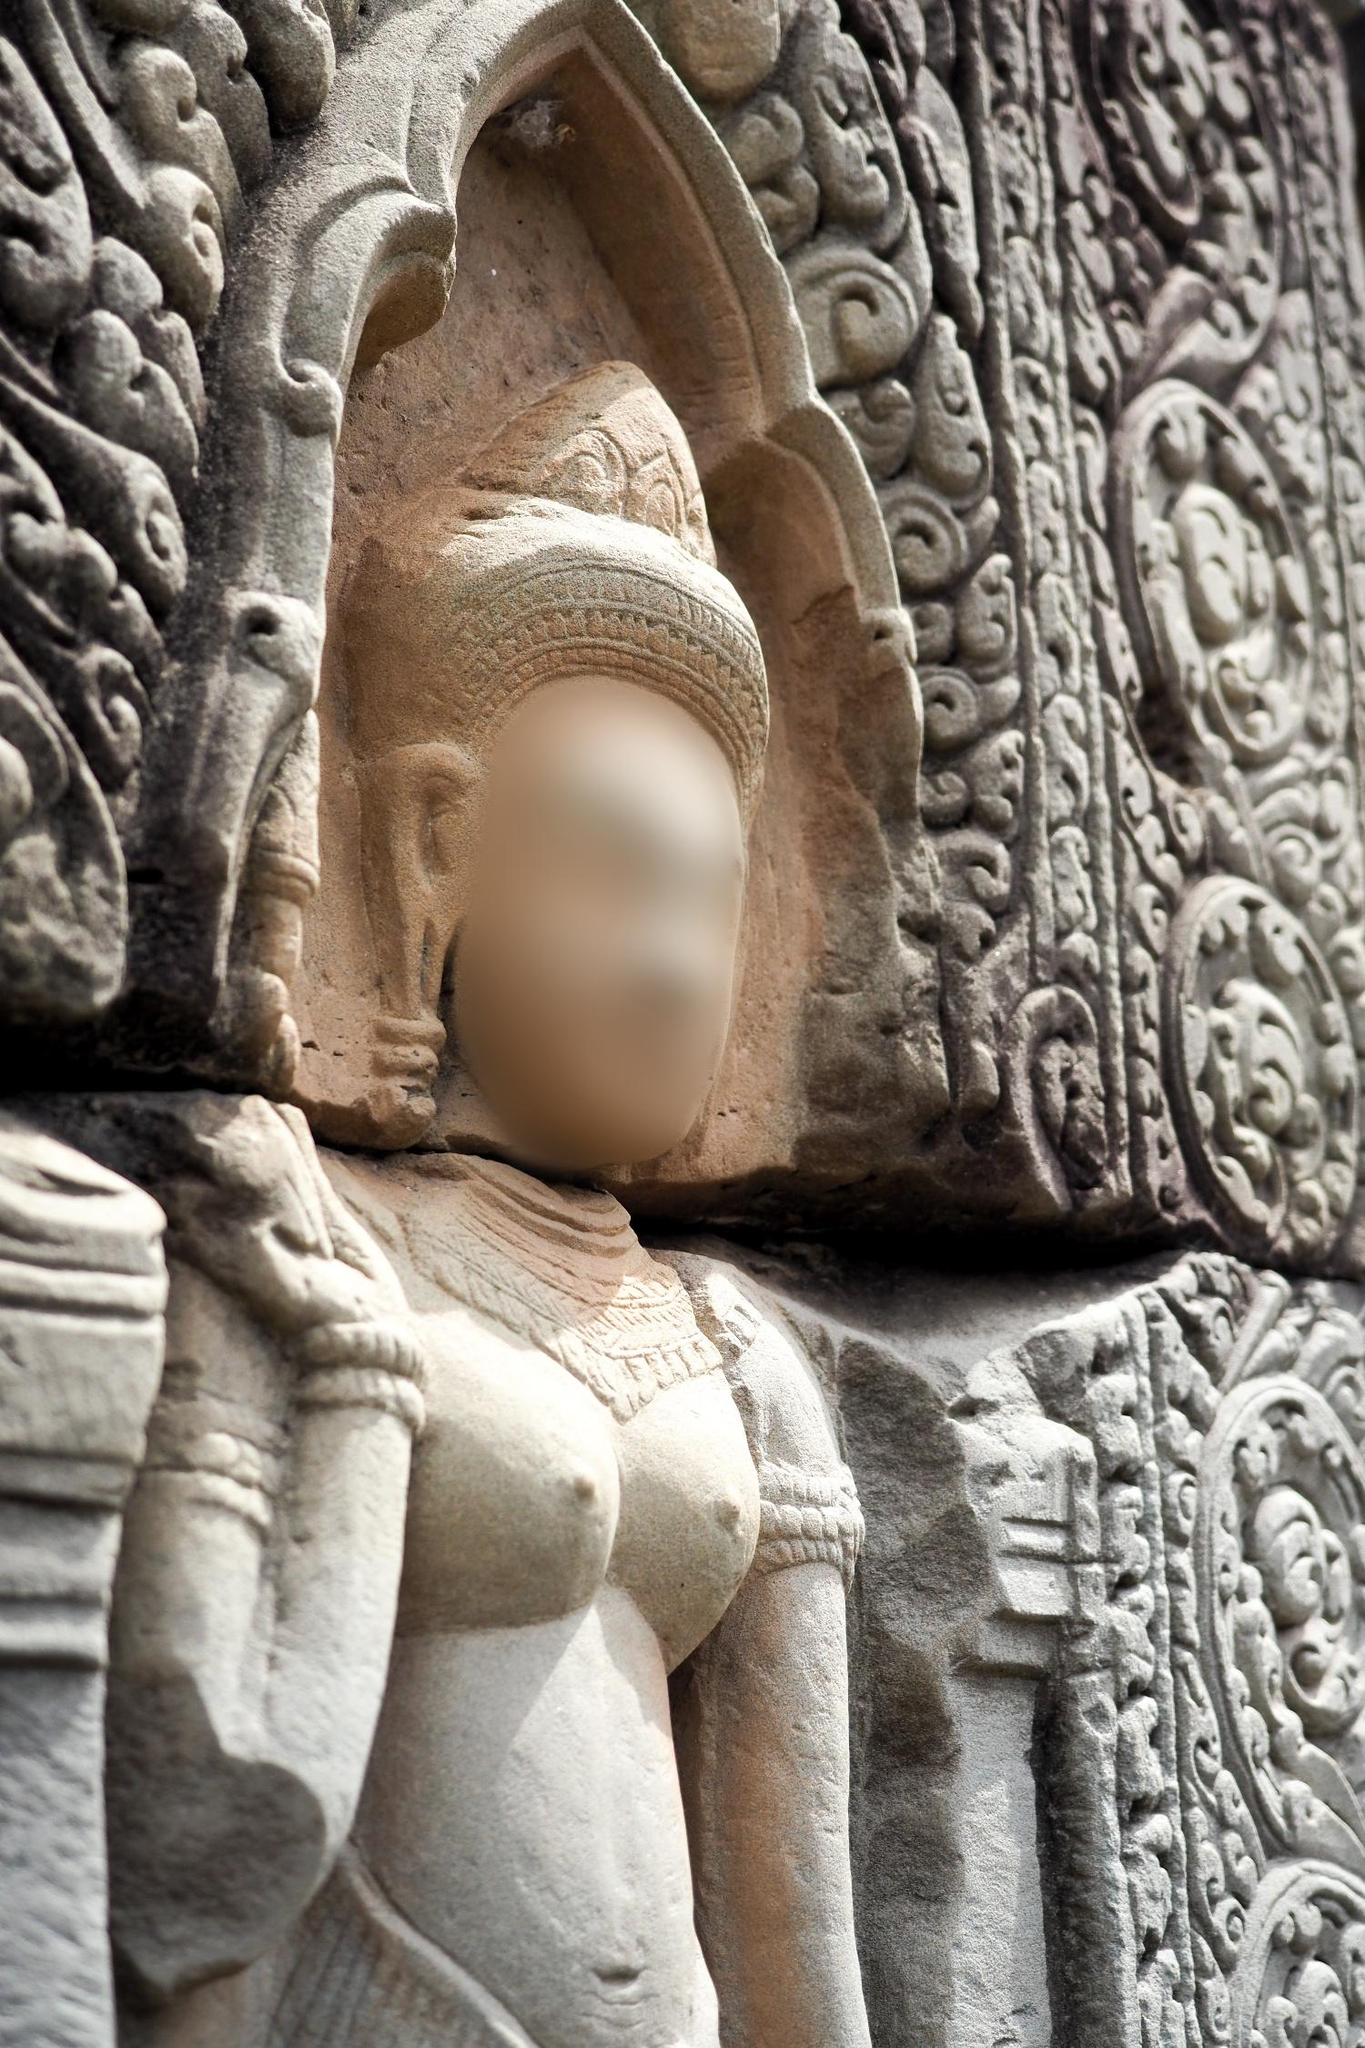Can you describe what the figure in the statue might be representing? The figure in the statue likely represents a deity or important personage from a historical or spiritual context, given the elaborate headdress and ornate detailing. The presence of intricate carvings and the timeless stone material suggest that it holds significant cultural or religious value. This could be a depiction of a revered guardian or a divine entity, standing as a symbol of protection and reverence, holding untold myths and truths within its silent, stone-bound pose. What era might this statue belong to? Based on the sophisticated craftsmanship and the style of the carvings, this statue could belong to an ancient civilization, possibly from Southeast Asia. The style resembles that of Khmer or ancient Hindu sculpture, suggesting that it might date back to a period between the 9th to 15th centuries. Such statues often adorned temples and significant monuments, serving both decorative and symbolic purposes, and surviving the test of time to tell stories of civilizations long past. Imagine this statue could talk, what stories might it share? If the statue could speak, it might recount tales of its creation by skilled artisans, the labor of countless hands who carved its form from lifeless stone. It would tell stories of the ceremonies and offerings once laid at its feet, of the prayers and chants that echoed in the temple halls. Possibly, it could share the rise and fall of dynasties, the ebb and flow of devotees, and the serenity of centuries of silent vigilance. It might also narrate the legends of heroes and gods, revealing forgotten myths and ancient lore that has been passed down through generations only to fade with time. What makes this statue unique in comparison to modern sculptures? This statue's uniqueness lies in its historical profundity and the intricate skill of ancient craftsmanship that modern tools often emulate but rarely replicate in spirit or context. Unlike modern sculptures, which can be innovative and diverse in materials and techniques, this statue embodies the traditions, cultural values, and religious beliefs of its era. Its timeless presence speaks of a continuum of history and spirituality, preserving the aesthetics, artistic expressions, and sacred narratives of a civilization long past. The blurred face adds an air of mystery, making it not just a visual artifact but a catalyst for imagination and exploration of human heritage. 